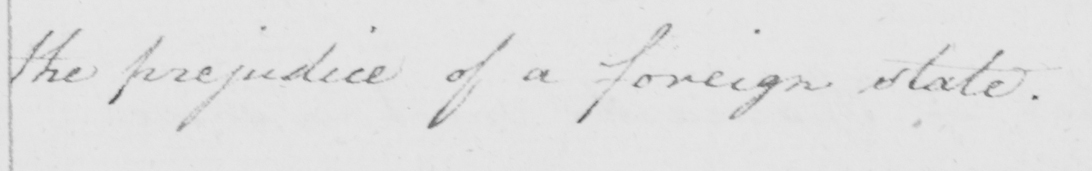Please transcribe the handwritten text in this image. the prejudice of a foreign state . 